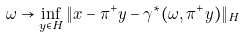<formula> <loc_0><loc_0><loc_500><loc_500>\omega \to \inf _ { y \in H } \| x - \pi ^ { + } y - \gamma ^ { \ast } ( \omega , \pi ^ { + } y ) \| _ { H }</formula> 